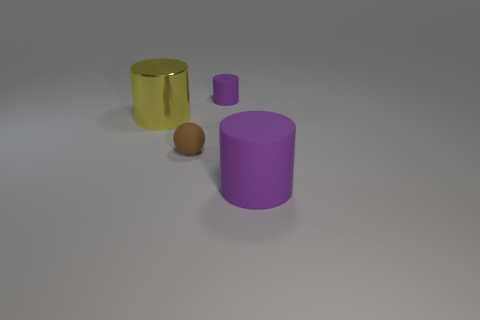Add 4 large purple cylinders. How many objects exist? 8 Subtract all purple cylinders. How many cylinders are left? 1 Subtract all yellow cylinders. How many cylinders are left? 2 Subtract all cylinders. How many objects are left? 1 Subtract all gray cubes. How many yellow cylinders are left? 1 Add 1 purple matte things. How many purple matte things are left? 3 Add 4 big purple cylinders. How many big purple cylinders exist? 5 Subtract 0 red blocks. How many objects are left? 4 Subtract 1 balls. How many balls are left? 0 Subtract all yellow cylinders. Subtract all purple cubes. How many cylinders are left? 2 